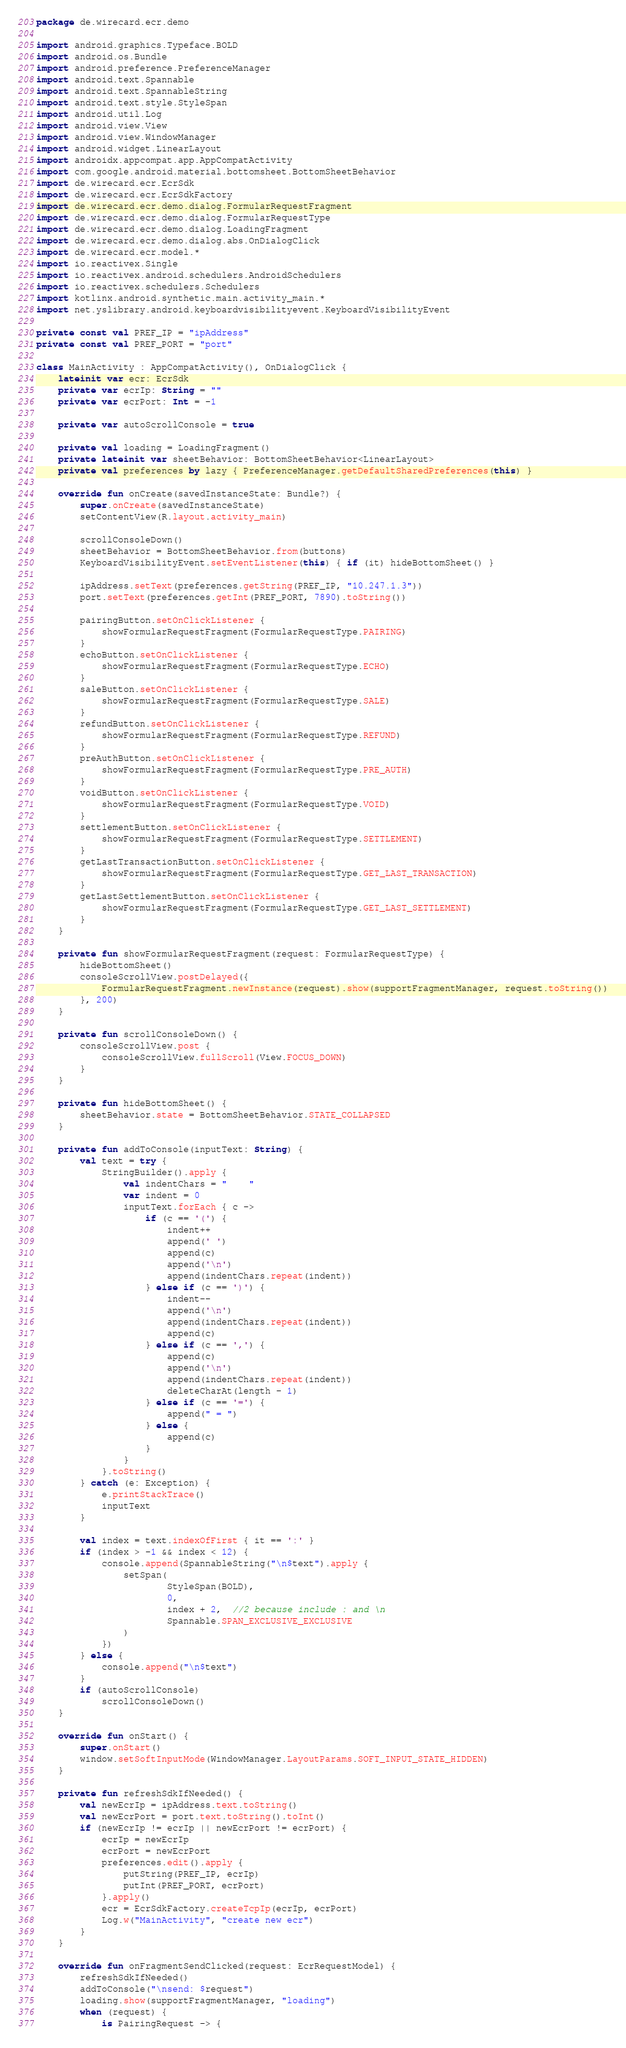Convert code to text. <code><loc_0><loc_0><loc_500><loc_500><_Kotlin_>package de.wirecard.ecr.demo

import android.graphics.Typeface.BOLD
import android.os.Bundle
import android.preference.PreferenceManager
import android.text.Spannable
import android.text.SpannableString
import android.text.style.StyleSpan
import android.util.Log
import android.view.View
import android.view.WindowManager
import android.widget.LinearLayout
import androidx.appcompat.app.AppCompatActivity
import com.google.android.material.bottomsheet.BottomSheetBehavior
import de.wirecard.ecr.EcrSdk
import de.wirecard.ecr.EcrSdkFactory
import de.wirecard.ecr.demo.dialog.FormularRequestFragment
import de.wirecard.ecr.demo.dialog.FormularRequestType
import de.wirecard.ecr.demo.dialog.LoadingFragment
import de.wirecard.ecr.demo.dialog.abs.OnDialogClick
import de.wirecard.ecr.model.*
import io.reactivex.Single
import io.reactivex.android.schedulers.AndroidSchedulers
import io.reactivex.schedulers.Schedulers
import kotlinx.android.synthetic.main.activity_main.*
import net.yslibrary.android.keyboardvisibilityevent.KeyboardVisibilityEvent

private const val PREF_IP = "ipAddress"
private const val PREF_PORT = "port"

class MainActivity : AppCompatActivity(), OnDialogClick {
    lateinit var ecr: EcrSdk
    private var ecrIp: String = ""
    private var ecrPort: Int = -1

    private var autoScrollConsole = true

    private val loading = LoadingFragment()
    private lateinit var sheetBehavior: BottomSheetBehavior<LinearLayout>
    private val preferences by lazy { PreferenceManager.getDefaultSharedPreferences(this) }

    override fun onCreate(savedInstanceState: Bundle?) {
        super.onCreate(savedInstanceState)
        setContentView(R.layout.activity_main)

        scrollConsoleDown()
        sheetBehavior = BottomSheetBehavior.from(buttons)
        KeyboardVisibilityEvent.setEventListener(this) { if (it) hideBottomSheet() }

        ipAddress.setText(preferences.getString(PREF_IP, "10.247.1.3"))
        port.setText(preferences.getInt(PREF_PORT, 7890).toString())

        pairingButton.setOnClickListener {
            showFormularRequestFragment(FormularRequestType.PAIRING)
        }
        echoButton.setOnClickListener {
            showFormularRequestFragment(FormularRequestType.ECHO)
        }
        saleButton.setOnClickListener {
            showFormularRequestFragment(FormularRequestType.SALE)
        }
        refundButton.setOnClickListener {
            showFormularRequestFragment(FormularRequestType.REFUND)
        }
        preAuthButton.setOnClickListener {
            showFormularRequestFragment(FormularRequestType.PRE_AUTH)
        }
        voidButton.setOnClickListener {
            showFormularRequestFragment(FormularRequestType.VOID)
        }
        settlementButton.setOnClickListener {
            showFormularRequestFragment(FormularRequestType.SETTLEMENT)
        }
        getLastTransactionButton.setOnClickListener {
            showFormularRequestFragment(FormularRequestType.GET_LAST_TRANSACTION)
        }
        getLastSettlementButton.setOnClickListener {
            showFormularRequestFragment(FormularRequestType.GET_LAST_SETTLEMENT)
        }
    }

    private fun showFormularRequestFragment(request: FormularRequestType) {
        hideBottomSheet()
        consoleScrollView.postDelayed({
            FormularRequestFragment.newInstance(request).show(supportFragmentManager, request.toString())
        }, 200)
    }

    private fun scrollConsoleDown() {
        consoleScrollView.post {
            consoleScrollView.fullScroll(View.FOCUS_DOWN)
        }
    }

    private fun hideBottomSheet() {
        sheetBehavior.state = BottomSheetBehavior.STATE_COLLAPSED
    }

    private fun addToConsole(inputText: String) {
        val text = try {
            StringBuilder().apply {
                val indentChars = "    "
                var indent = 0
                inputText.forEach { c ->
                    if (c == '(') {
                        indent++
                        append(' ')
                        append(c)
                        append('\n')
                        append(indentChars.repeat(indent))
                    } else if (c == ')') {
                        indent--
                        append('\n')
                        append(indentChars.repeat(indent))
                        append(c)
                    } else if (c == ',') {
                        append(c)
                        append('\n')
                        append(indentChars.repeat(indent))
                        deleteCharAt(length - 1)
                    } else if (c == '=') {
                        append(" = ")
                    } else {
                        append(c)
                    }
                }
            }.toString()
        } catch (e: Exception) {
            e.printStackTrace()
            inputText
        }

        val index = text.indexOfFirst { it == ':' }
        if (index > -1 && index < 12) {
            console.append(SpannableString("\n$text").apply {
                setSpan(
                        StyleSpan(BOLD),
                        0,
                        index + 2,  //2 because include : and \n
                        Spannable.SPAN_EXCLUSIVE_EXCLUSIVE
                )
            })
        } else {
            console.append("\n$text")
        }
        if (autoScrollConsole)
            scrollConsoleDown()
    }

    override fun onStart() {
        super.onStart()
        window.setSoftInputMode(WindowManager.LayoutParams.SOFT_INPUT_STATE_HIDDEN)
    }

    private fun refreshSdkIfNeeded() {
        val newEcrIp = ipAddress.text.toString()
        val newEcrPort = port.text.toString().toInt()
        if (newEcrIp != ecrIp || newEcrPort != ecrPort) {
            ecrIp = newEcrIp
            ecrPort = newEcrPort
            preferences.edit().apply {
                putString(PREF_IP, ecrIp)
                putInt(PREF_PORT, ecrPort)
            }.apply()
            ecr = EcrSdkFactory.createTcpIp(ecrIp, ecrPort)
            Log.w("MainActivity", "create new ecr")
        }
    }

    override fun onFragmentSendClicked(request: EcrRequestModel) {
        refreshSdkIfNeeded()
        addToConsole("\nsend: $request")
        loading.show(supportFragmentManager, "loading")
        when (request) {
            is PairingRequest -> {</code> 